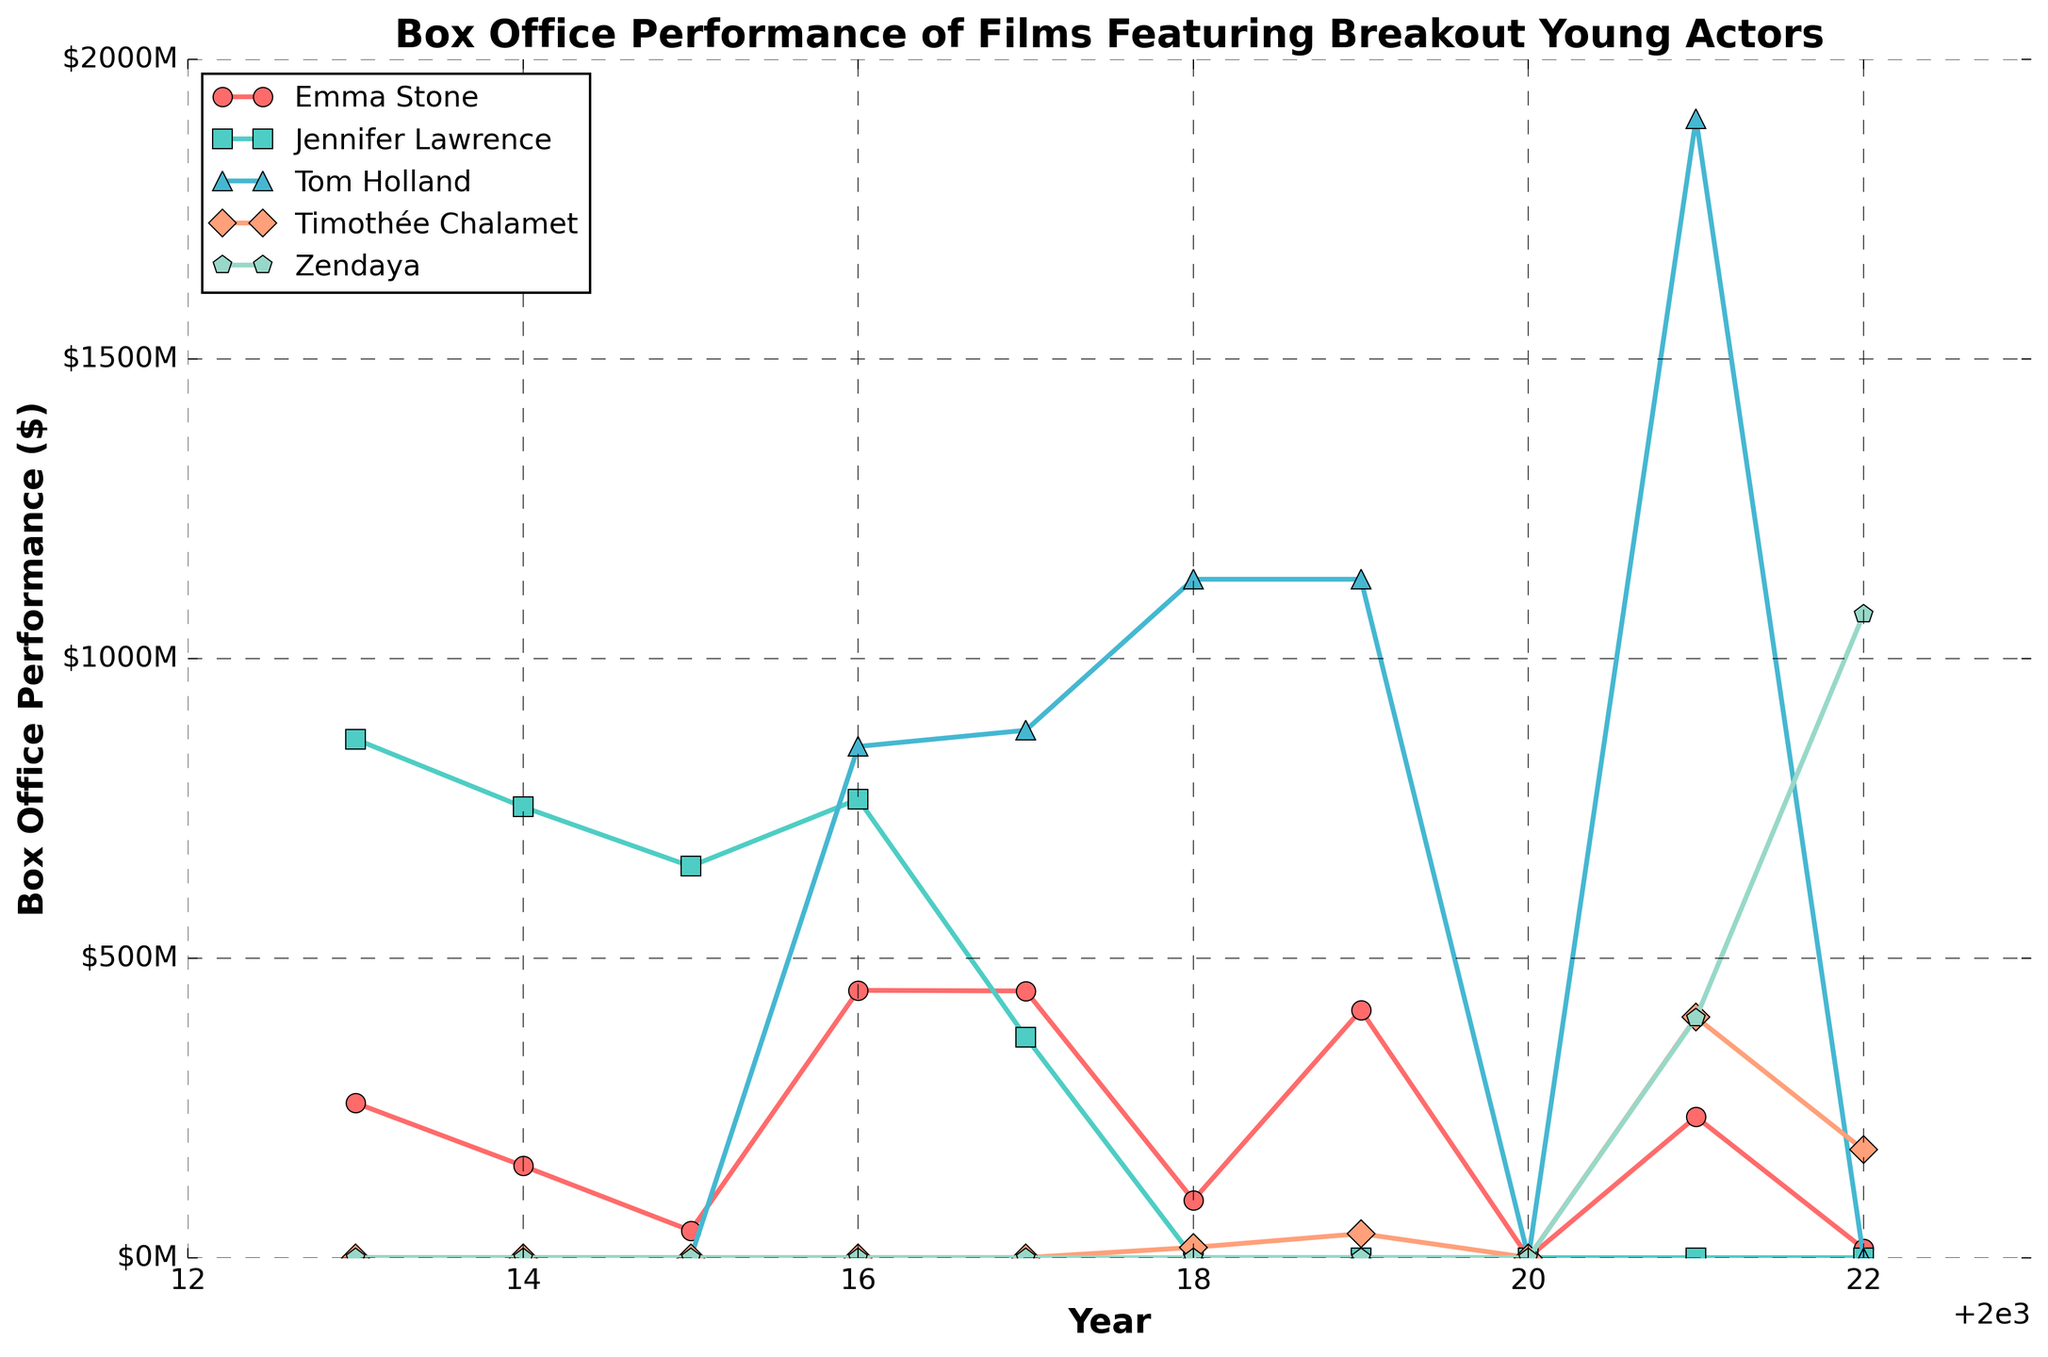What year did Jennifer Lawrence achieve her highest box office performance? Look at the line for Jennifer Lawrence, which is represented by a specific color, and identify the peak.
Answer: 2013 Which actor had the highest box office performance in 2021? Compare the values for all actors in the year 2021 and identify the highest one.
Answer: Tom Holland What is the difference in box office performance between Emma Stone in 2014 and 2015? Subtract the 2015 value for Emma Stone from her 2014 value.
Answer: 108,000,000 In which years did Emma Stone's films have a box office performance greater than $400M? Check the years when Emma Stone's line crosses the $400M mark.
Answer: 2016, 2017, 2019 How many times did Zendaya's films achieve a box office performance? Count the years for which Zendaya has a non-zero value.
Answer: 2 Between 2018 and 2019, did Tom Holland's box office performance increase or decrease? Compare the values for Tom Holland in 2018 and 2019.
Answer: Same What is the combined box office performance of Timothée Chalamet and Zendaya in 2021? Add the box office performance values for Timothée Chalamet and Zendaya in 2021.
Answer: 801,000,000 Which actor had a zero box office performance in both 2018 and 2019? Identify the actor whose values are zero for both years 2018 and 2019.
Answer: Jennifer Lawrence What distinct visual attribute helps you identify the data line for Tom Holland? Describe the visual attributes (color, marker) used for Tom Holland's data line.
Answer: Tom Holland's data line is marked with a specific color and a tri-pointed marker 